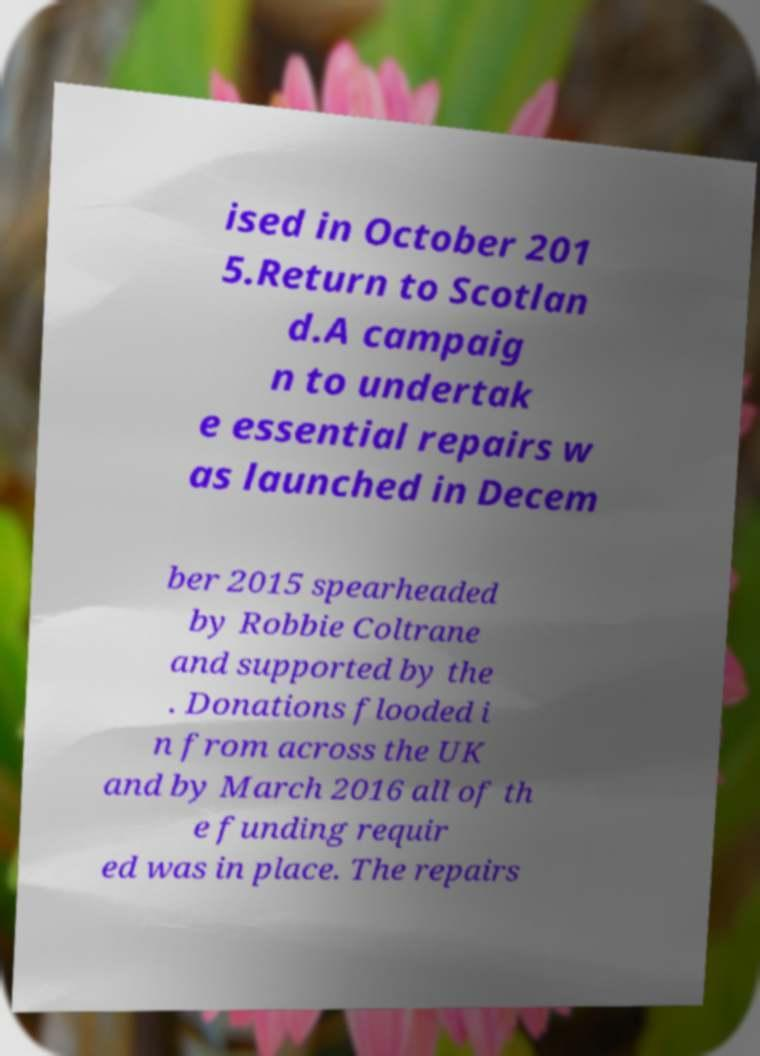Could you extract and type out the text from this image? ised in October 201 5.Return to Scotlan d.A campaig n to undertak e essential repairs w as launched in Decem ber 2015 spearheaded by Robbie Coltrane and supported by the . Donations flooded i n from across the UK and by March 2016 all of th e funding requir ed was in place. The repairs 